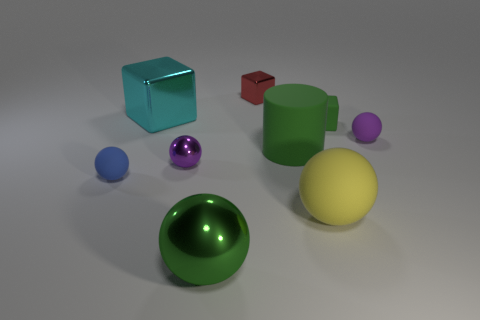Subtract all large spheres. How many spheres are left? 3 Subtract all cylinders. How many objects are left? 8 Add 1 large yellow rubber balls. How many objects exist? 10 Subtract all blue balls. How many balls are left? 4 Subtract 1 blocks. How many blocks are left? 2 Subtract all cyan balls. Subtract all gray cylinders. How many balls are left? 5 Subtract all brown balls. How many cyan cubes are left? 1 Subtract all big green rubber cylinders. Subtract all metal spheres. How many objects are left? 6 Add 1 cylinders. How many cylinders are left? 2 Add 2 tiny red rubber objects. How many tiny red rubber objects exist? 2 